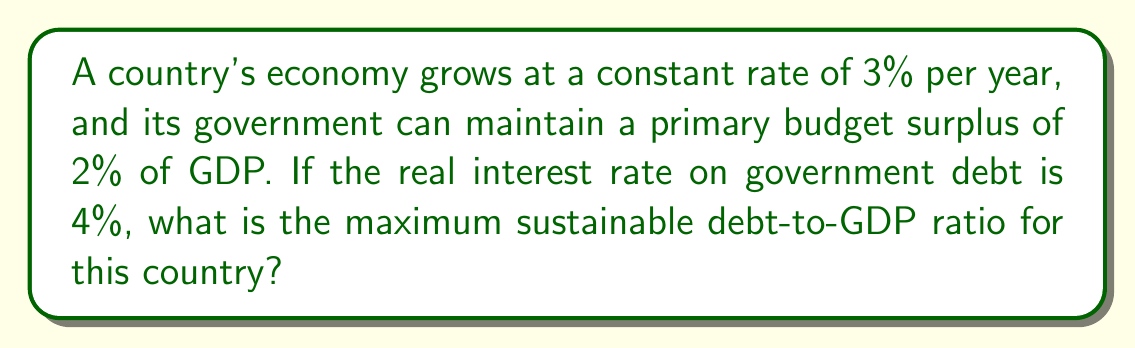Can you answer this question? To find the maximum sustainable debt-to-GDP ratio, we need to use the debt sustainability equation:

$$ \frac{d(t+1)}{y(t+1)} = \frac{1+r}{1+g} \cdot \frac{d(t)}{y(t)} - s $$

Where:
$d(t)$ is the debt at time $t$
$y(t)$ is the GDP at time $t$
$r$ is the real interest rate
$g$ is the GDP growth rate
$s$ is the primary budget surplus as a fraction of GDP

For the debt-to-GDP ratio to be sustainable, it should remain constant over time. This means:

$$ \frac{d(t+1)}{y(t+1)} = \frac{d(t)}{y(t)} $$

Let's call this sustainable ratio $x$. Substituting into our equation:

$$ x = \frac{1+r}{1+g} \cdot x - s $$

Now, let's plug in our given values:
$r = 0.04$ (4%)
$g = 0.03$ (3%)
$s = 0.02$ (2%)

$$ x = \frac{1.04}{1.03} \cdot x - 0.02 $$

Simplifying:

$$ x = 1.0097087379 \cdot x - 0.02 $$

Subtracting $1.0097087379 \cdot x$ from both sides:

$$ -0.0097087379 \cdot x = -0.02 $$

Dividing both sides by $-0.0097087379$:

$$ x = \frac{0.02}{0.0097087379} \approx 2.0600 $$

Therefore, the maximum sustainable debt-to-GDP ratio is approximately 206%.
Answer: 206% 